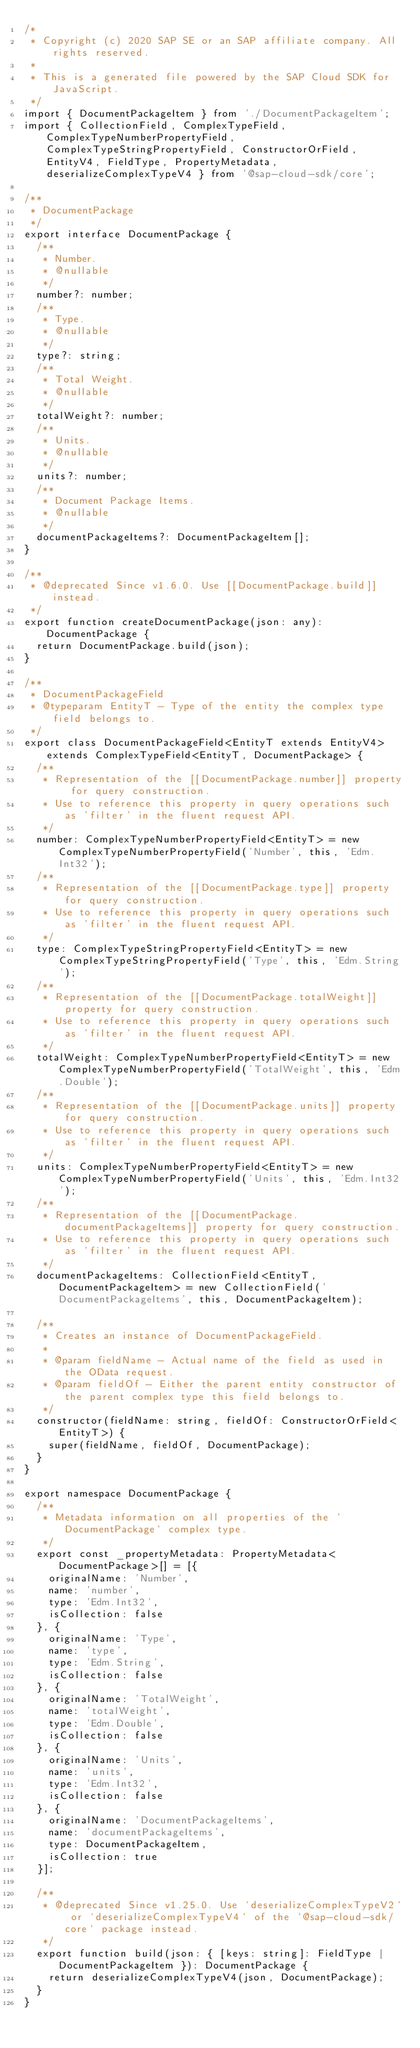<code> <loc_0><loc_0><loc_500><loc_500><_TypeScript_>/*
 * Copyright (c) 2020 SAP SE or an SAP affiliate company. All rights reserved.
 *
 * This is a generated file powered by the SAP Cloud SDK for JavaScript.
 */
import { DocumentPackageItem } from './DocumentPackageItem';
import { CollectionField, ComplexTypeField, ComplexTypeNumberPropertyField, ComplexTypeStringPropertyField, ConstructorOrField, EntityV4, FieldType, PropertyMetadata, deserializeComplexTypeV4 } from '@sap-cloud-sdk/core';

/**
 * DocumentPackage
 */
export interface DocumentPackage {
  /**
   * Number.
   * @nullable
   */
  number?: number;
  /**
   * Type.
   * @nullable
   */
  type?: string;
  /**
   * Total Weight.
   * @nullable
   */
  totalWeight?: number;
  /**
   * Units.
   * @nullable
   */
  units?: number;
  /**
   * Document Package Items.
   * @nullable
   */
  documentPackageItems?: DocumentPackageItem[];
}

/**
 * @deprecated Since v1.6.0. Use [[DocumentPackage.build]] instead.
 */
export function createDocumentPackage(json: any): DocumentPackage {
  return DocumentPackage.build(json);
}

/**
 * DocumentPackageField
 * @typeparam EntityT - Type of the entity the complex type field belongs to.
 */
export class DocumentPackageField<EntityT extends EntityV4> extends ComplexTypeField<EntityT, DocumentPackage> {
  /**
   * Representation of the [[DocumentPackage.number]] property for query construction.
   * Use to reference this property in query operations such as 'filter' in the fluent request API.
   */
  number: ComplexTypeNumberPropertyField<EntityT> = new ComplexTypeNumberPropertyField('Number', this, 'Edm.Int32');
  /**
   * Representation of the [[DocumentPackage.type]] property for query construction.
   * Use to reference this property in query operations such as 'filter' in the fluent request API.
   */
  type: ComplexTypeStringPropertyField<EntityT> = new ComplexTypeStringPropertyField('Type', this, 'Edm.String');
  /**
   * Representation of the [[DocumentPackage.totalWeight]] property for query construction.
   * Use to reference this property in query operations such as 'filter' in the fluent request API.
   */
  totalWeight: ComplexTypeNumberPropertyField<EntityT> = new ComplexTypeNumberPropertyField('TotalWeight', this, 'Edm.Double');
  /**
   * Representation of the [[DocumentPackage.units]] property for query construction.
   * Use to reference this property in query operations such as 'filter' in the fluent request API.
   */
  units: ComplexTypeNumberPropertyField<EntityT> = new ComplexTypeNumberPropertyField('Units', this, 'Edm.Int32');
  /**
   * Representation of the [[DocumentPackage.documentPackageItems]] property for query construction.
   * Use to reference this property in query operations such as 'filter' in the fluent request API.
   */
  documentPackageItems: CollectionField<EntityT, DocumentPackageItem> = new CollectionField('DocumentPackageItems', this, DocumentPackageItem);

  /**
   * Creates an instance of DocumentPackageField.
   *
   * @param fieldName - Actual name of the field as used in the OData request.
   * @param fieldOf - Either the parent entity constructor of the parent complex type this field belongs to.
   */
  constructor(fieldName: string, fieldOf: ConstructorOrField<EntityT>) {
    super(fieldName, fieldOf, DocumentPackage);
  }
}

export namespace DocumentPackage {
  /**
   * Metadata information on all properties of the `DocumentPackage` complex type.
   */
  export const _propertyMetadata: PropertyMetadata<DocumentPackage>[] = [{
    originalName: 'Number',
    name: 'number',
    type: 'Edm.Int32',
    isCollection: false
  }, {
    originalName: 'Type',
    name: 'type',
    type: 'Edm.String',
    isCollection: false
  }, {
    originalName: 'TotalWeight',
    name: 'totalWeight',
    type: 'Edm.Double',
    isCollection: false
  }, {
    originalName: 'Units',
    name: 'units',
    type: 'Edm.Int32',
    isCollection: false
  }, {
    originalName: 'DocumentPackageItems',
    name: 'documentPackageItems',
    type: DocumentPackageItem,
    isCollection: true
  }];

  /**
   * @deprecated Since v1.25.0. Use `deserializeComplexTypeV2` or `deserializeComplexTypeV4` of the `@sap-cloud-sdk/core` package instead.
   */
  export function build(json: { [keys: string]: FieldType | DocumentPackageItem }): DocumentPackage {
    return deserializeComplexTypeV4(json, DocumentPackage);
  }
}
</code> 